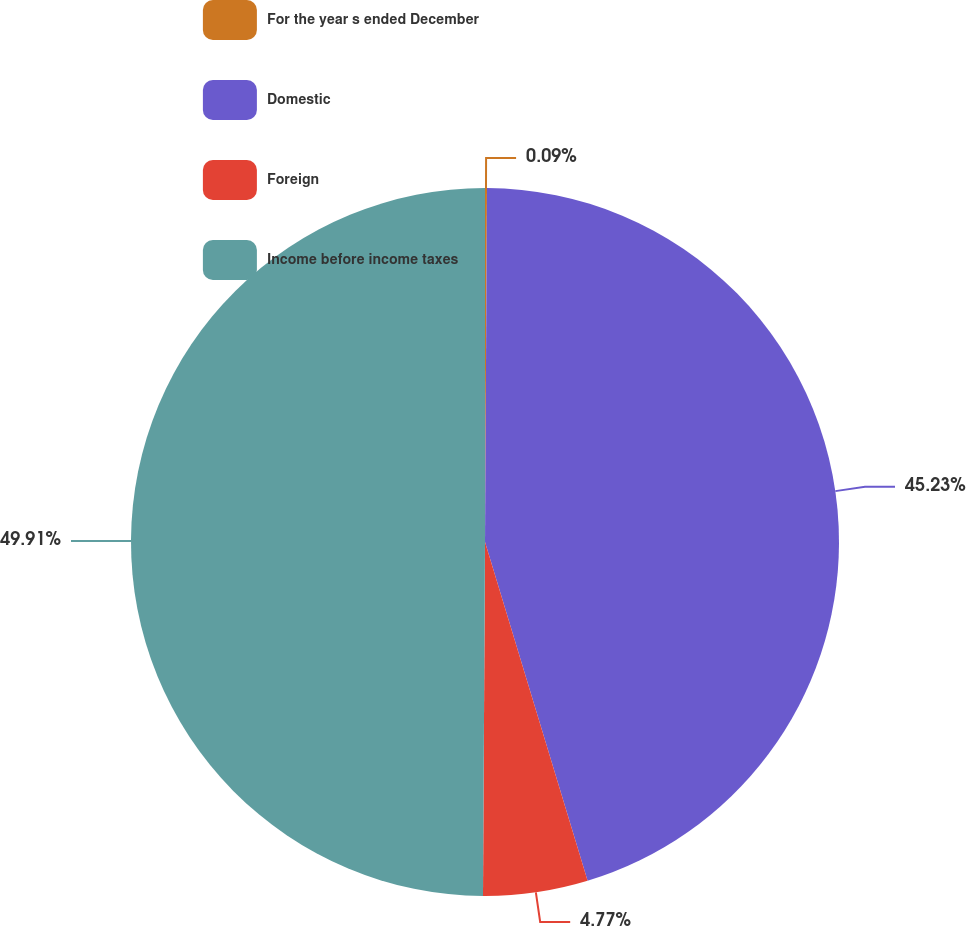Convert chart. <chart><loc_0><loc_0><loc_500><loc_500><pie_chart><fcel>For the year s ended December<fcel>Domestic<fcel>Foreign<fcel>Income before income taxes<nl><fcel>0.09%<fcel>45.23%<fcel>4.77%<fcel>49.91%<nl></chart> 